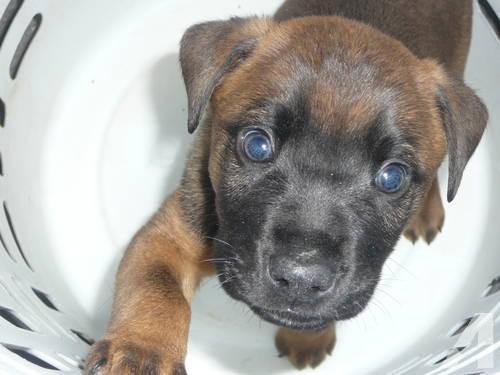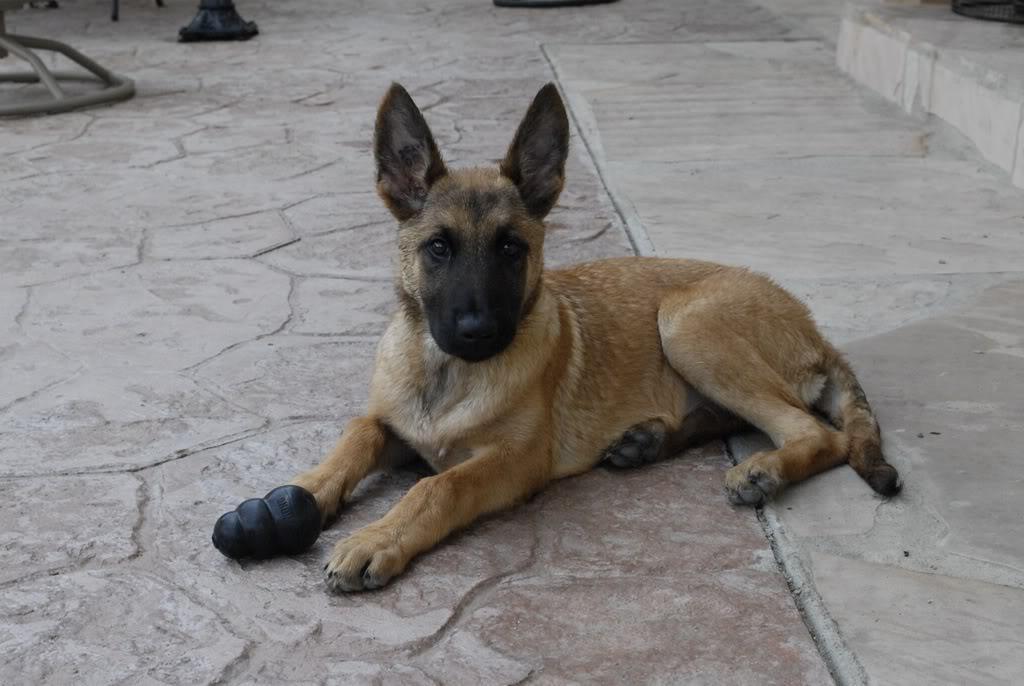The first image is the image on the left, the second image is the image on the right. For the images shown, is this caption "A large-eared dog's tongue is visible as it faces the camera." true? Answer yes or no. No. The first image is the image on the left, the second image is the image on the right. For the images shown, is this caption "There is at least one dog sticking its tongue out." true? Answer yes or no. No. 